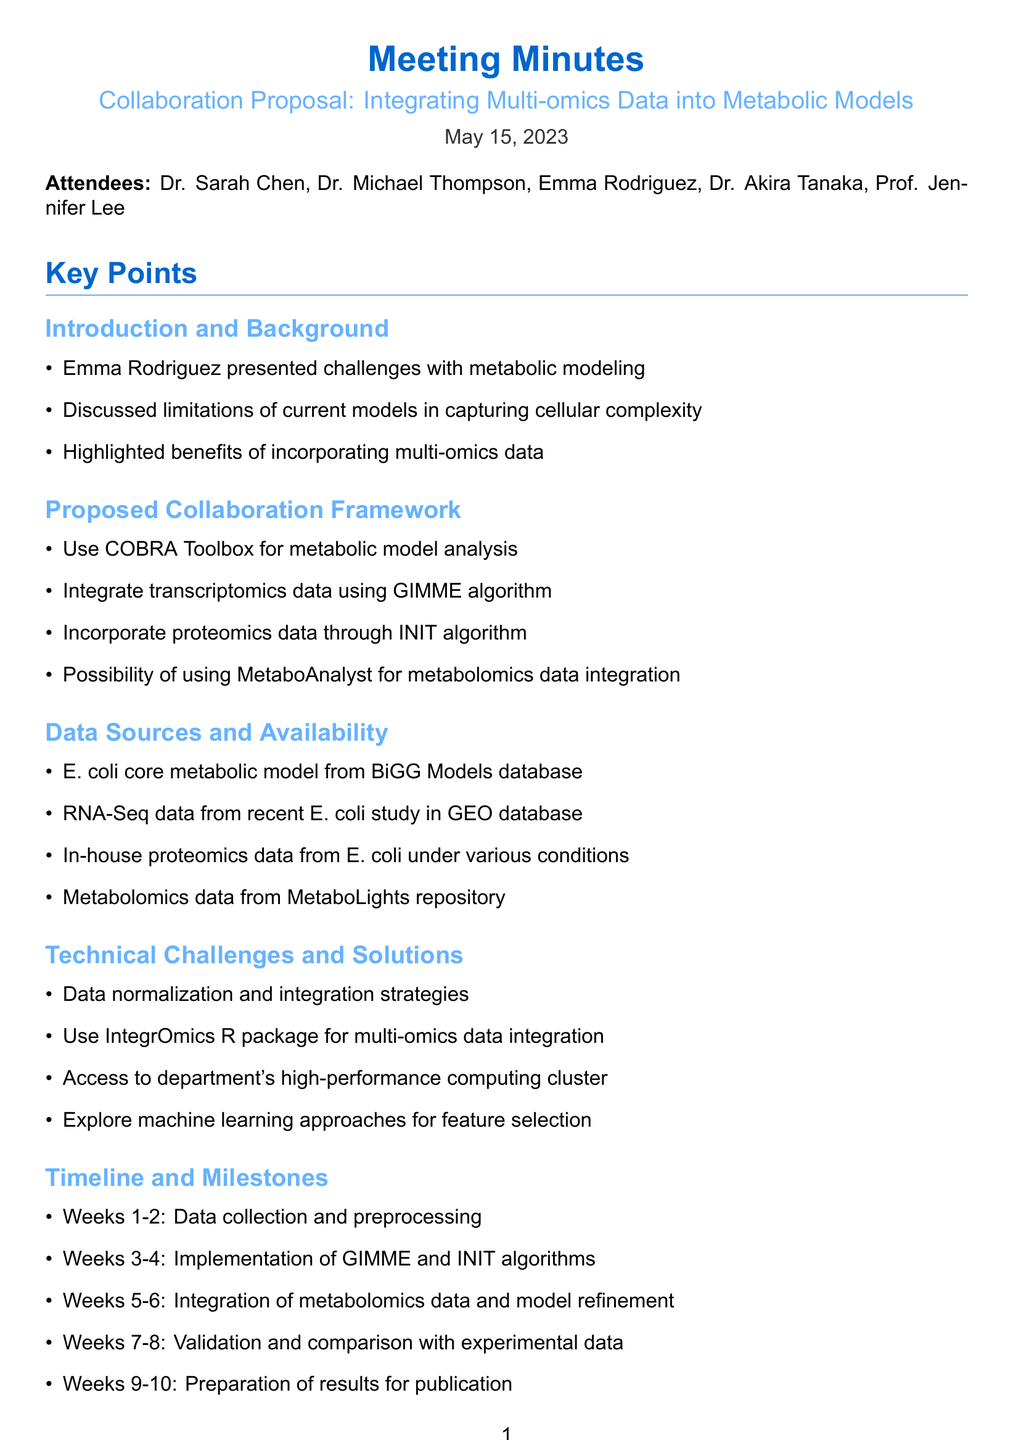What is the date of the meeting? The date of the meeting is noted at the beginning of the document as the meeting date.
Answer: May 15, 2023 Who is the lead of the Bioinformatics Research Group? The document mentions Dr. Sarah Chen as the Bioinformatics Research Group Lead in the attendees section.
Answer: Dr. Sarah Chen What is the primary focus of the proposed collaboration? The main topic of the collaboration proposal is outlined in the meeting title, focusing on multi-omics data integration.
Answer: Integrating Multi-omics Data into Metabolic Models Which algorithm was recommended for integrating transcriptomics data? Dr. Thompson's recommendation in the proposed collaboration framework includes a specific algorithm for transcriptomics data.
Answer: GIMME algorithm How many hours per week is Emma dedicating to the project? The document states the resource allocation and specifically mentions Emma's commitment for the project.
Answer: 20 hours per week What is the expected outcome related to metabolic fluxes? The expected outcome related to metabolic fluxes is mentioned in the outcomes section, addressing improvement in modeling predictions.
Answer: Improved prediction accuracy of metabolic fluxes What is the timeline for the validation phase? The timeline outlines specific weeks dedicated to the validation phase within the overall project timeline.
Answer: Weeks 7-8 Who proposed the tutorial on omics data preprocessing? The document lists the responsible attendees for each task, indicating who will prepare the tutorial.
Answer: Dr. Tanaka What package is suggested for multi-omics data integration? The technical challenges section mentions a specific package for integrating multi-omics data.
Answer: IntegrOmics R package 